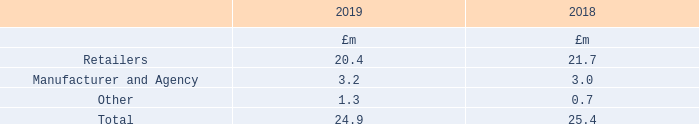The maximum exposure to credit risk for trade receivables at the reporting date by type of customer was:
The Group’s most significant customer accounts for £0.5m (2018: £0.6m) of net trade receivables as at 31 March 2019.
What information does the table provide? The maximum exposure to credit risk for trade receivables at the reporting date by type of customer. How much did the Group's most significant customer account for? £0.5m (2018: £0.6m) of net trade receivables. What were the components making up the maximum exposure to credit risk for trade receivables at the reporting date by type of customer? Retailers, manufacturer and agency, other. In which year was the amount of Other larger? 1.3>0.7
Answer: 2019. What was the change in Other in 2019 from 2018?
Answer scale should be: million. 1.3-0.7
Answer: 0.6. What was the percentage change in Other in 2019 from 2018?
Answer scale should be: percent. (1.3-0.7)/0.7
Answer: 85.71. 